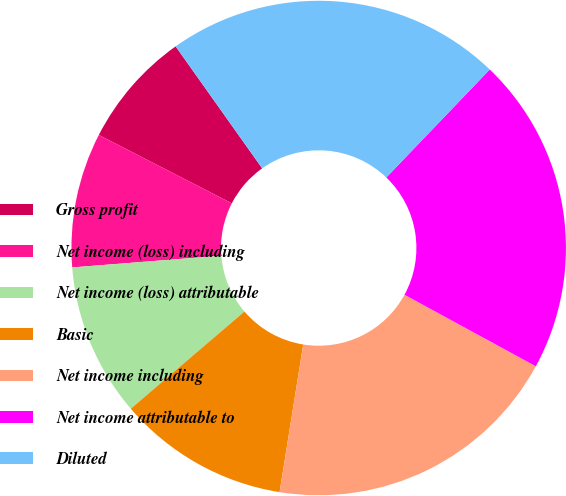Convert chart to OTSL. <chart><loc_0><loc_0><loc_500><loc_500><pie_chart><fcel>Gross profit<fcel>Net income (loss) including<fcel>Net income (loss) attributable<fcel>Basic<fcel>Net income including<fcel>Net income attributable to<fcel>Diluted<nl><fcel>7.62%<fcel>8.81%<fcel>10.01%<fcel>11.21%<fcel>19.59%<fcel>20.78%<fcel>21.98%<nl></chart> 